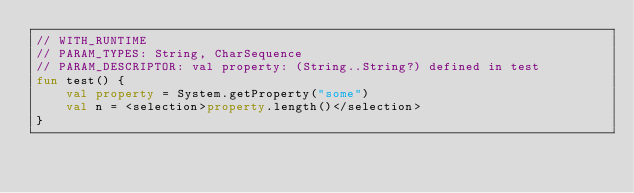Convert code to text. <code><loc_0><loc_0><loc_500><loc_500><_Kotlin_>// WITH_RUNTIME
// PARAM_TYPES: String, CharSequence
// PARAM_DESCRIPTOR: val property: (String..String?) defined in test
fun test() {
    val property = System.getProperty("some")
    val n = <selection>property.length()</selection>
}</code> 